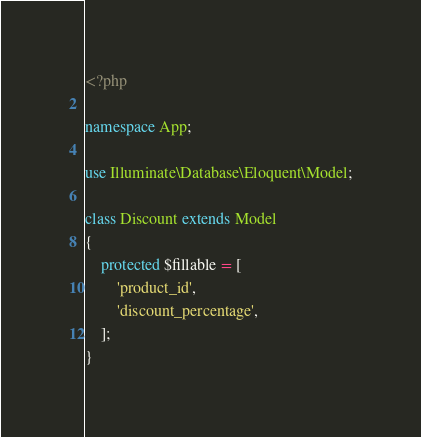<code> <loc_0><loc_0><loc_500><loc_500><_PHP_><?php

namespace App;

use Illuminate\Database\Eloquent\Model;

class Discount extends Model
{
    protected $fillable = [
        'product_id',
        'discount_percentage',
    ];
}
</code> 